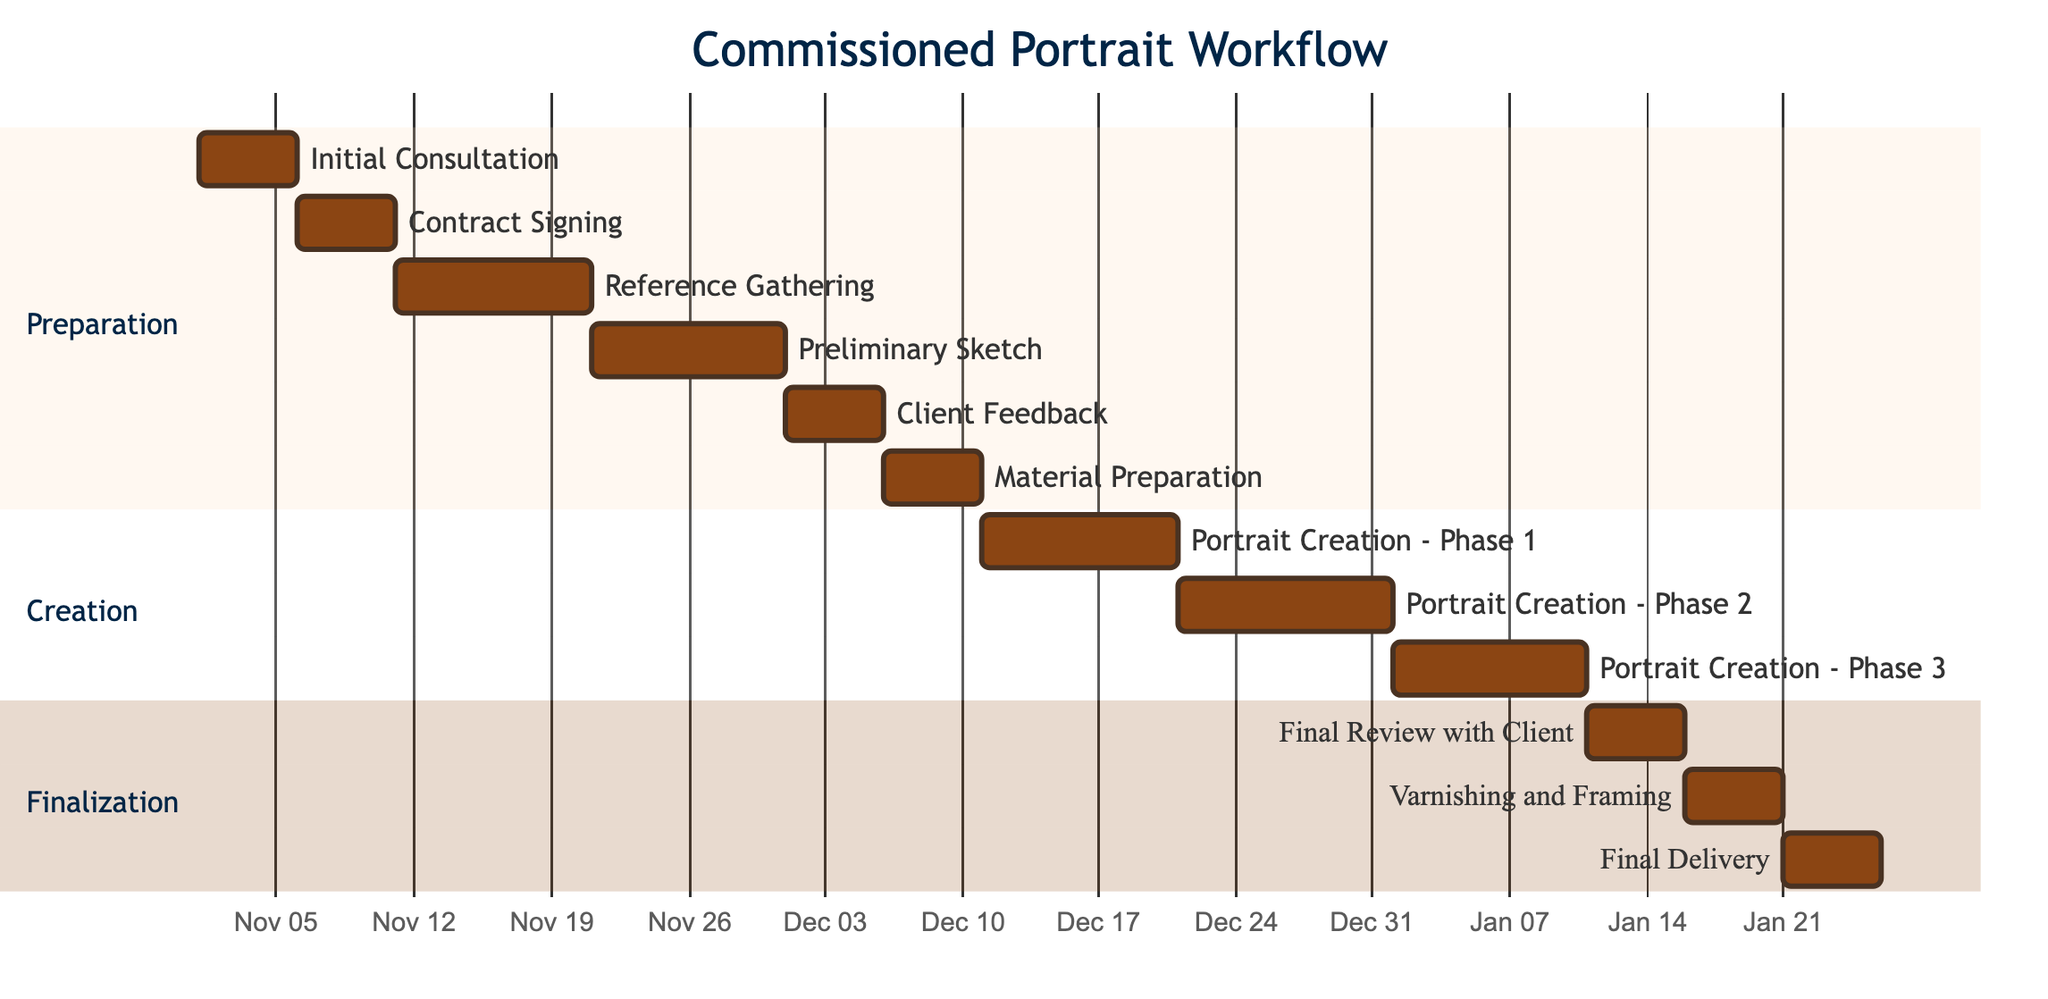What is the duration of the Initial Consultation task? The Initial Consultation task starts on November 1, 2023, and ends on November 5, 2023. The duration can be calculated as the difference between the end and start dates, which is 5 days.
Answer: 5 days Which task comes immediately after the Contract Signing? The task that follows Contract Signing, which finishes on November 10, 2023, is Reference Gathering, which starts on November 11, 2023. Therefore, Reference Gathering comes immediately after Contract Signing.
Answer: Reference Gathering How many tasks are there in the Creation section? Counting the tasks listed under the Creation section: Portrait Creation - Phase 1, Phase 2, and Phase 3, there are three tasks overall within this section.
Answer: 3 tasks What is the end date for the Final Delivery task? The Final Delivery task is scheduled to start on January 21, 2024, and end on January 25, 2024. Therefore, the end date for this task is January 25, 2024.
Answer: January 25, 2024 What is the total number of days allocated for the Portrait Creation phases combined? The total days for the three phases are: Phase 1 (10 days) + Phase 2 (11 days) + Phase 3 (10 days) = 31 days total. By summing the durations, we reach the final total of 31 days allocated for all phases.
Answer: 31 days 